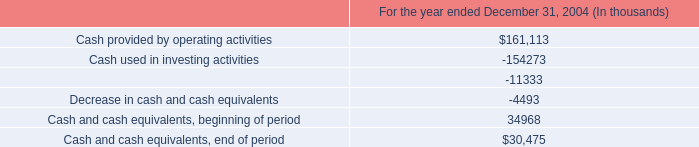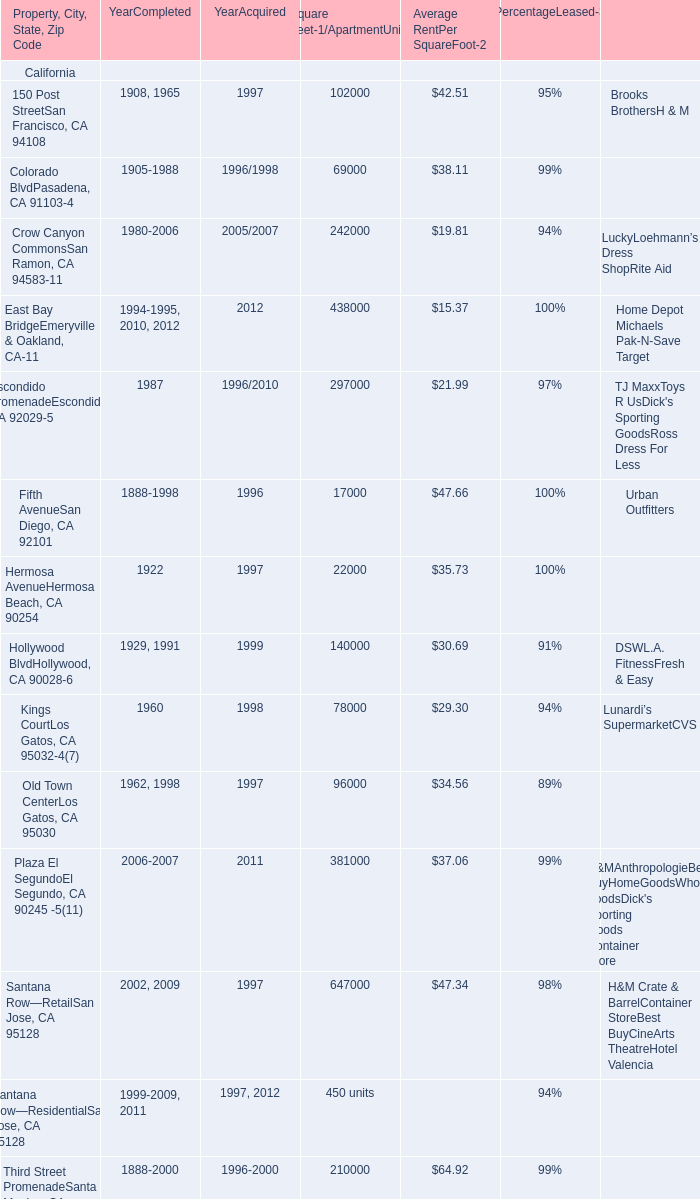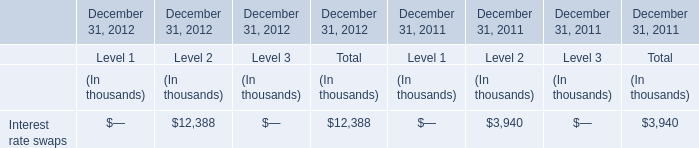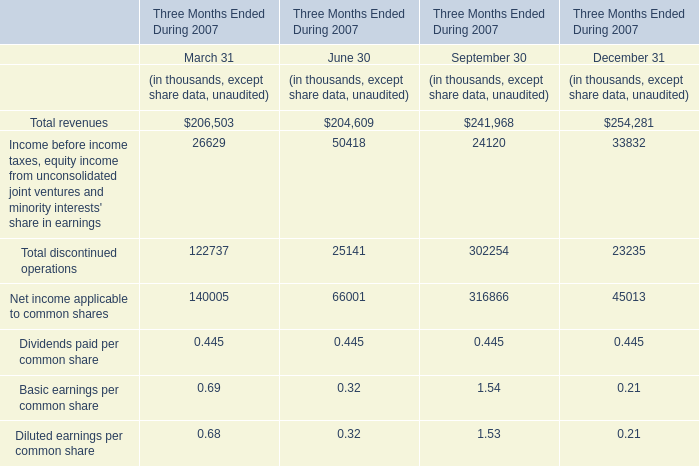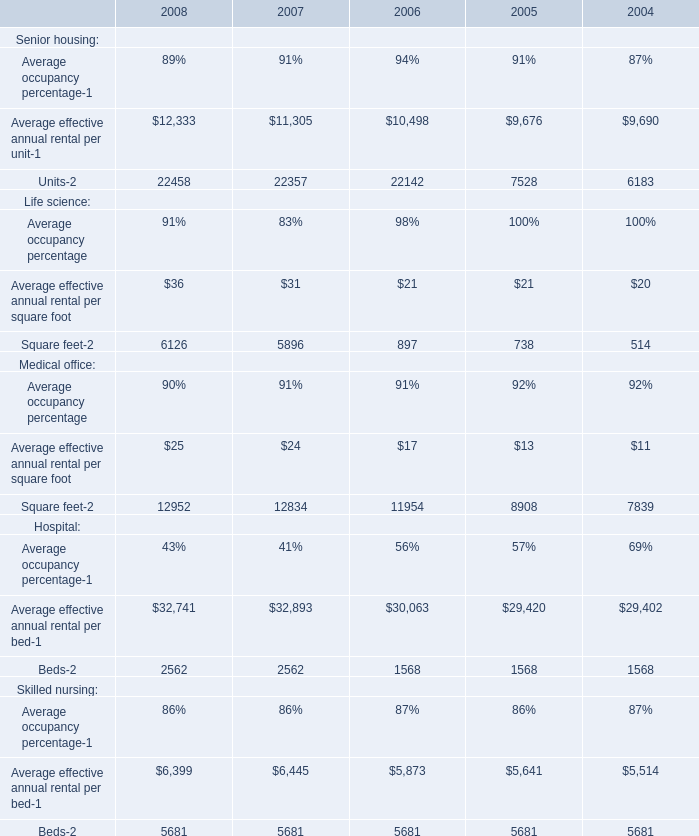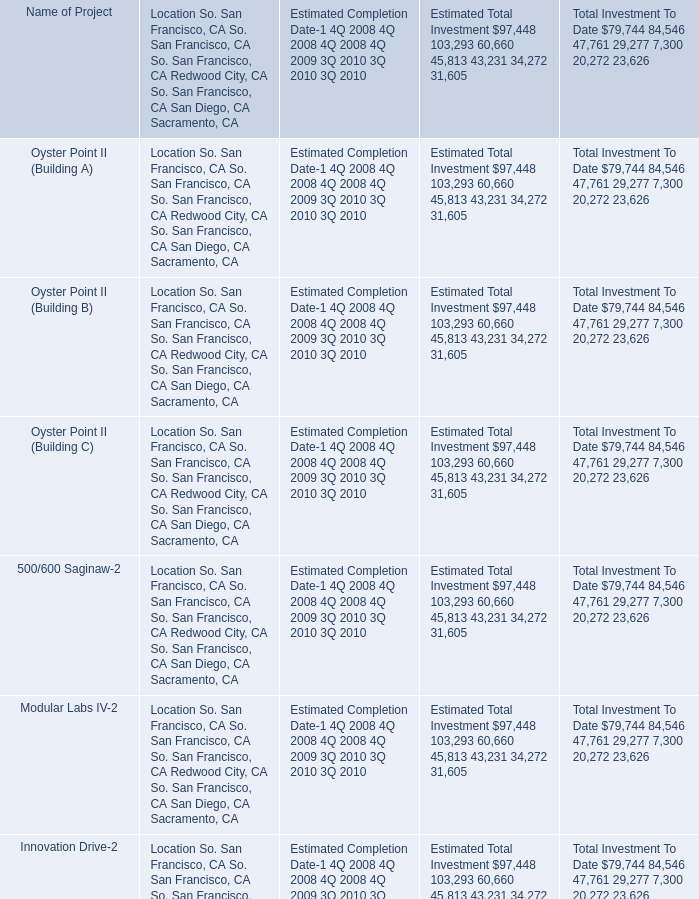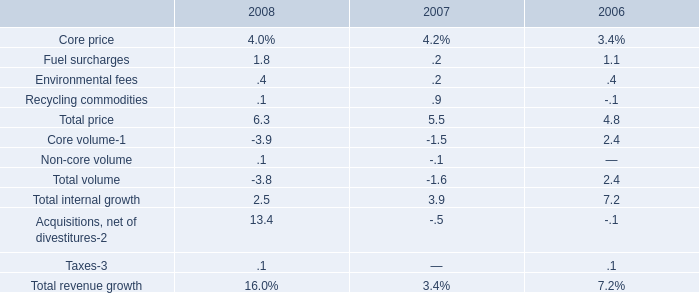What is the total value of Escondido PromenadeEscondido, CA 92029-5, iego, CA 92101,Hermosa AvenueHermosa Beach, CA 90254 and Hollywood BlvdHollywood, CA 90028-6 for Square Feet-1/ApartmentUnits ? 
Computations: (((297000 + 17000) + 22000) + 140000)
Answer: 476000.0. 